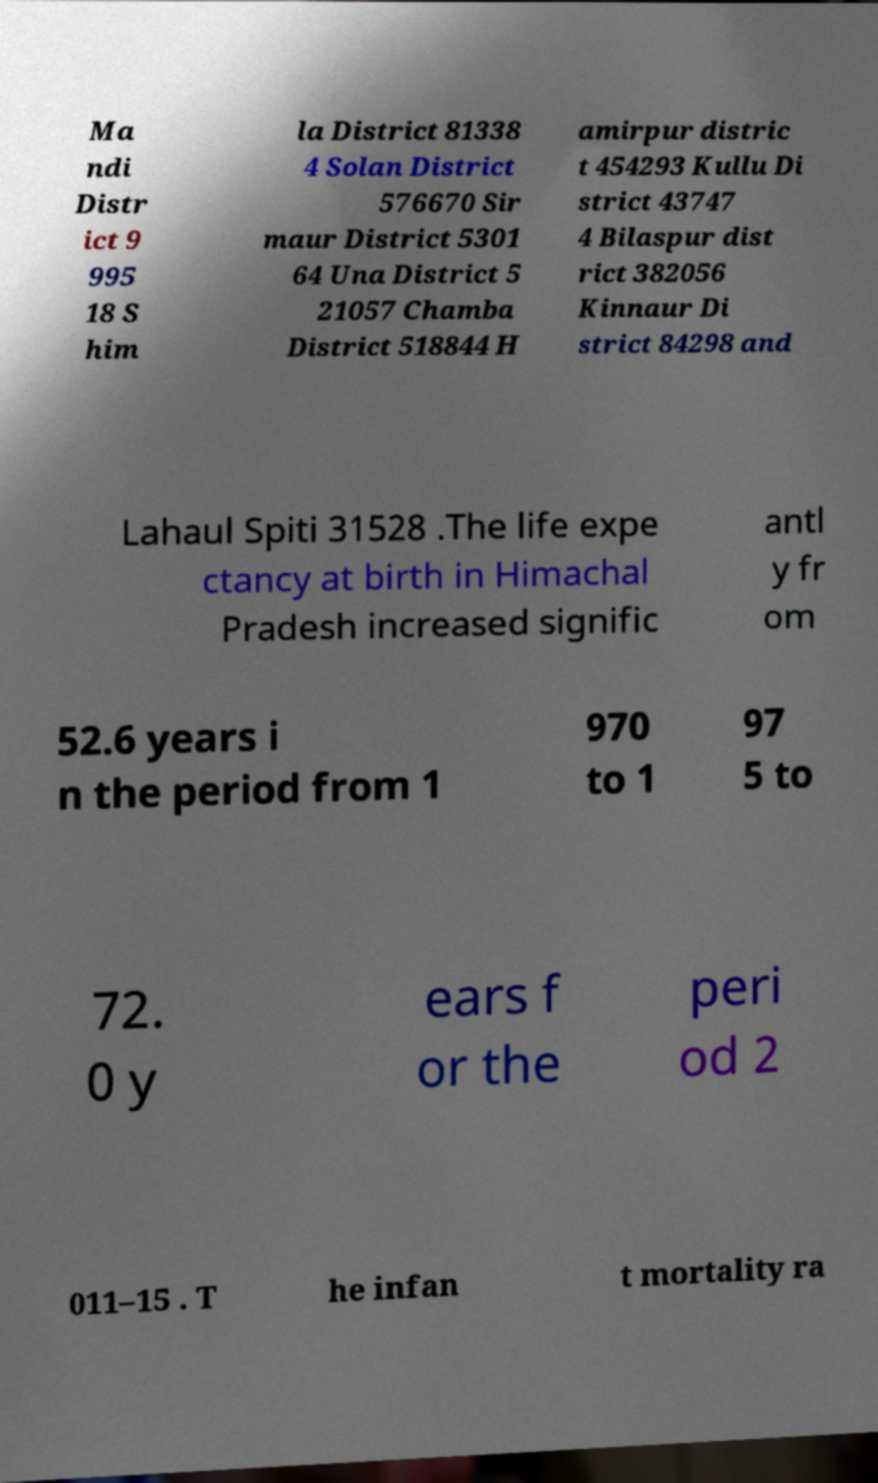There's text embedded in this image that I need extracted. Can you transcribe it verbatim? Ma ndi Distr ict 9 995 18 S him la District 81338 4 Solan District 576670 Sir maur District 5301 64 Una District 5 21057 Chamba District 518844 H amirpur distric t 454293 Kullu Di strict 43747 4 Bilaspur dist rict 382056 Kinnaur Di strict 84298 and Lahaul Spiti 31528 .The life expe ctancy at birth in Himachal Pradesh increased signific antl y fr om 52.6 years i n the period from 1 970 to 1 97 5 to 72. 0 y ears f or the peri od 2 011–15 . T he infan t mortality ra 